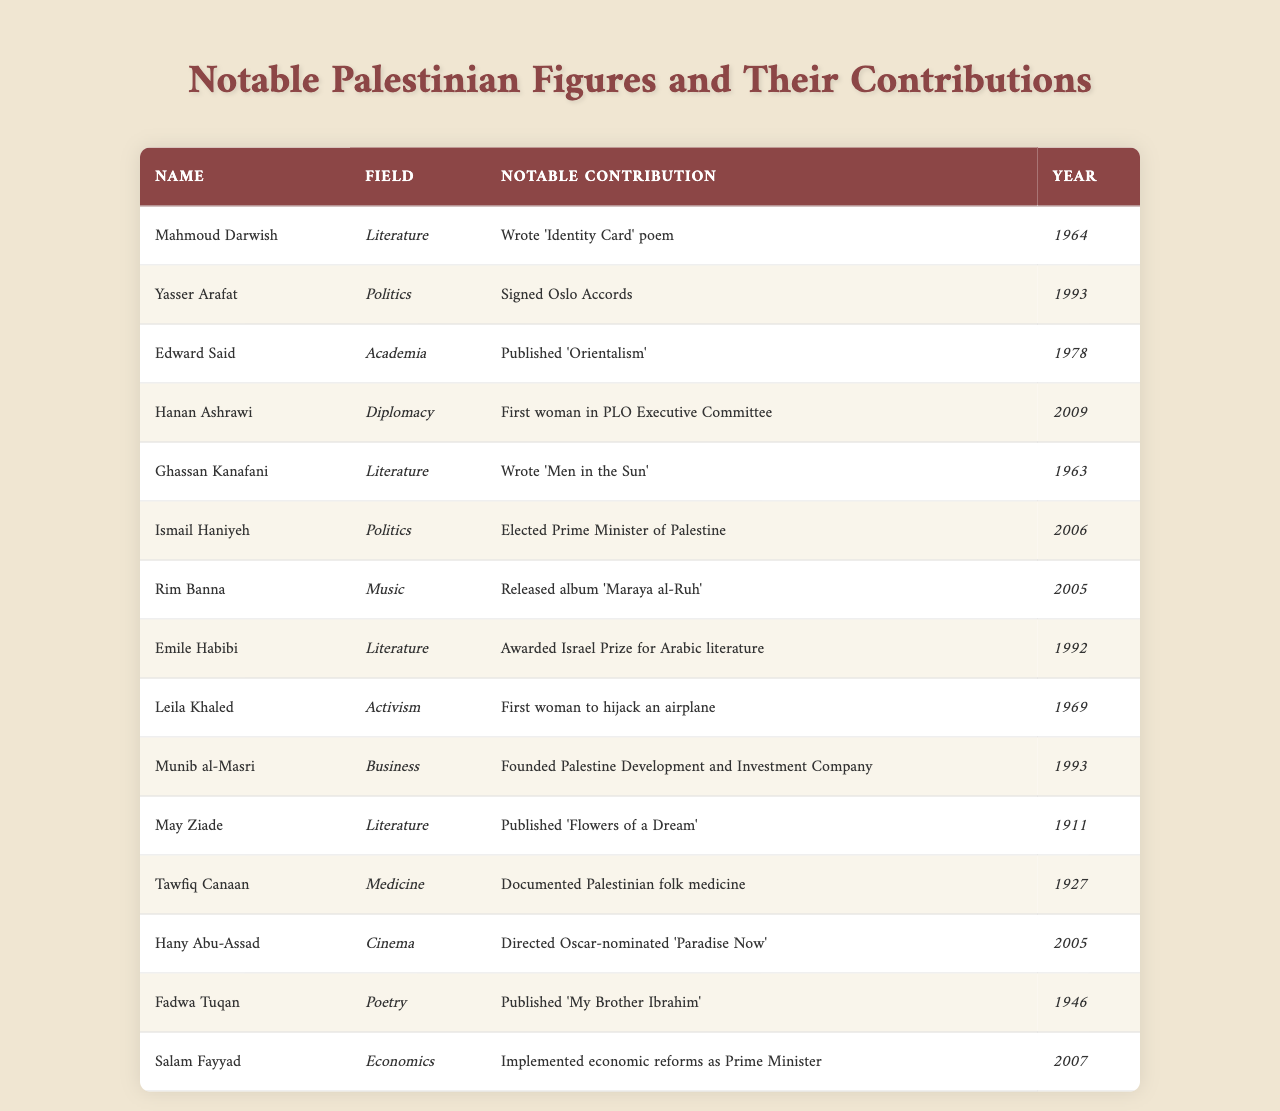What notable contribution did Mahmoud Darwish make? According to the table, Mahmoud Darwish wrote the poem "Identity Card" in 1964.
Answer: Wrote 'Identity Card' poem Which year did Yasser Arafat sign the Oslo Accords? The table indicates that Yasser Arafat signed the Oslo Accords in 1993.
Answer: 1993 Who was the first woman in the PLO Executive Committee? Hanan Ashrawi is listed in the table as the first woman in the PLO Executive Committee, appointed in 2009.
Answer: Hanan Ashrawi How many notable figures contributed to literature? By counting the rows, there are 5 figures associated with the field of literature: Mahmoud Darwish, Ghassan Kanafani, Emile Habibi, May Ziade, and Fadwa Tuqan.
Answer: 5 Did Edward Said publish 'Orientalism' before the year 1980? The table shows Edward Said published 'Orientalism' in 1978, which is before 1980, hence the answer is yes.
Answer: Yes What was the notable contribution of Leila Khaled? The table indicates that Leila Khaled's notable contribution was being the first woman to hijack an airplane in 1969.
Answer: First woman to hijack an airplane What is the average year of contribution for figures in the field of politics? The contributions in politics are from Yasser Arafat (1993), Ismail Haniyeh (2006), and the average year can be calculated: (1993 + 2006) / 2 = 1999.5, rounded down is 1999.
Answer: 1999 Did any figures contribute to multiple fields? The table does not list any figures with contributions in more than one field; all have only one specific field of contribution. Therefore, the answer is no.
Answer: No What notable contributions were made in the year 2005? The table shows two contributions in 2005: Rim Banna released an album 'Maraya al-Ruh' and Hany Abu-Assad directed 'Paradise Now'.
Answer: Rim Banna and Hany Abu-Assad Which literary figure was awarded the Israel Prize, and in what year? The table notes that Emile Habibi was awarded the Israel Prize for Arabic literature in 1992.
Answer: Emile Habibi, 1992 